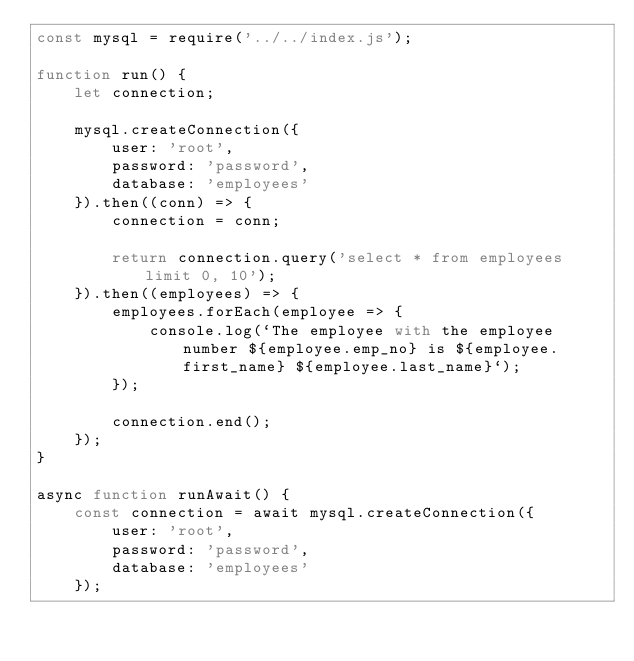<code> <loc_0><loc_0><loc_500><loc_500><_JavaScript_>const mysql = require('../../index.js');

function run() {
    let connection;

    mysql.createConnection({
        user: 'root',
        password: 'password',
        database: 'employees'
    }).then((conn) => {
        connection = conn;

        return connection.query('select * from employees limit 0, 10');
    }).then((employees) => {
        employees.forEach(employee => {
            console.log(`The employee with the employee number ${employee.emp_no} is ${employee.first_name} ${employee.last_name}`);
        });

        connection.end();
    });
}

async function runAwait() {
    const connection = await mysql.createConnection({
        user: 'root',
        password: 'password',
        database: 'employees'
    });
</code> 